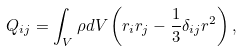Convert formula to latex. <formula><loc_0><loc_0><loc_500><loc_500>Q _ { i j } = \int _ { V } \rho d V \left ( r _ { i } r _ { j } - \frac { 1 } { 3 } \delta _ { i j } r ^ { 2 } \right ) ,</formula> 